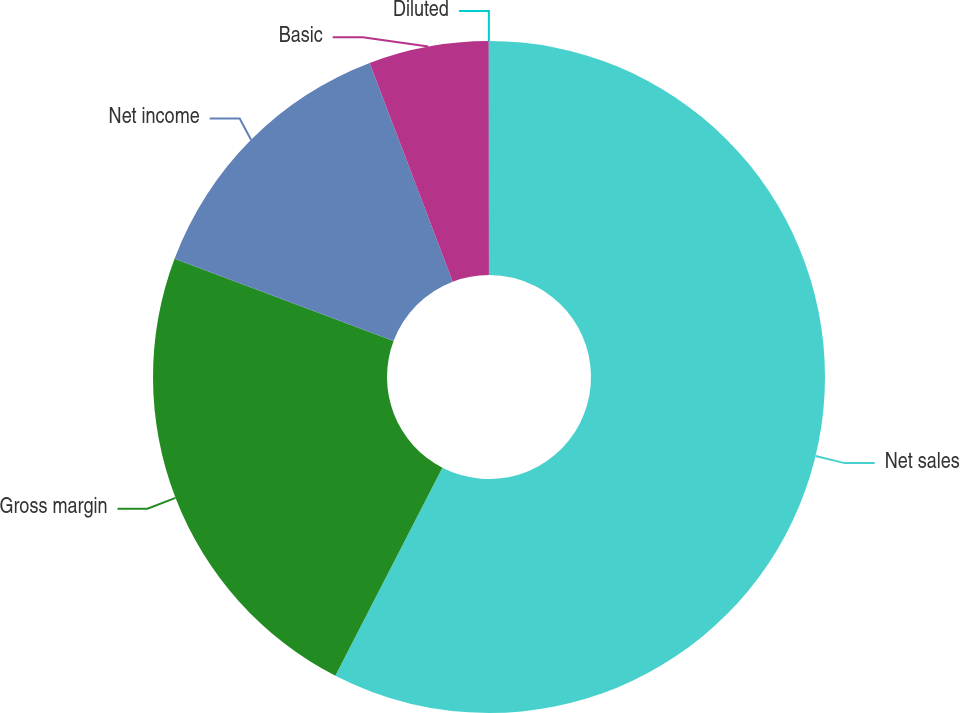<chart> <loc_0><loc_0><loc_500><loc_500><pie_chart><fcel>Net sales<fcel>Gross margin<fcel>Net income<fcel>Basic<fcel>Diluted<nl><fcel>57.56%<fcel>23.17%<fcel>13.49%<fcel>5.77%<fcel>0.01%<nl></chart> 